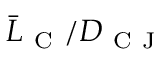Convert formula to latex. <formula><loc_0><loc_0><loc_500><loc_500>\bar { L } _ { C } / D _ { C J }</formula> 